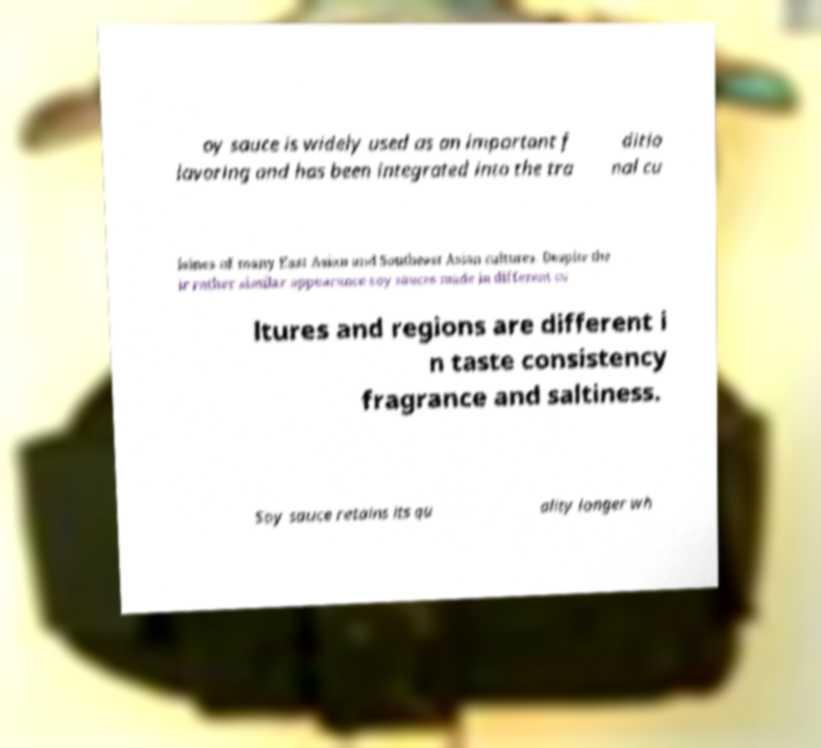Can you read and provide the text displayed in the image?This photo seems to have some interesting text. Can you extract and type it out for me? oy sauce is widely used as an important f lavoring and has been integrated into the tra ditio nal cu isines of many East Asian and Southeast Asian cultures. Despite the ir rather similar appearance soy sauces made in different cu ltures and regions are different i n taste consistency fragrance and saltiness. Soy sauce retains its qu ality longer wh 